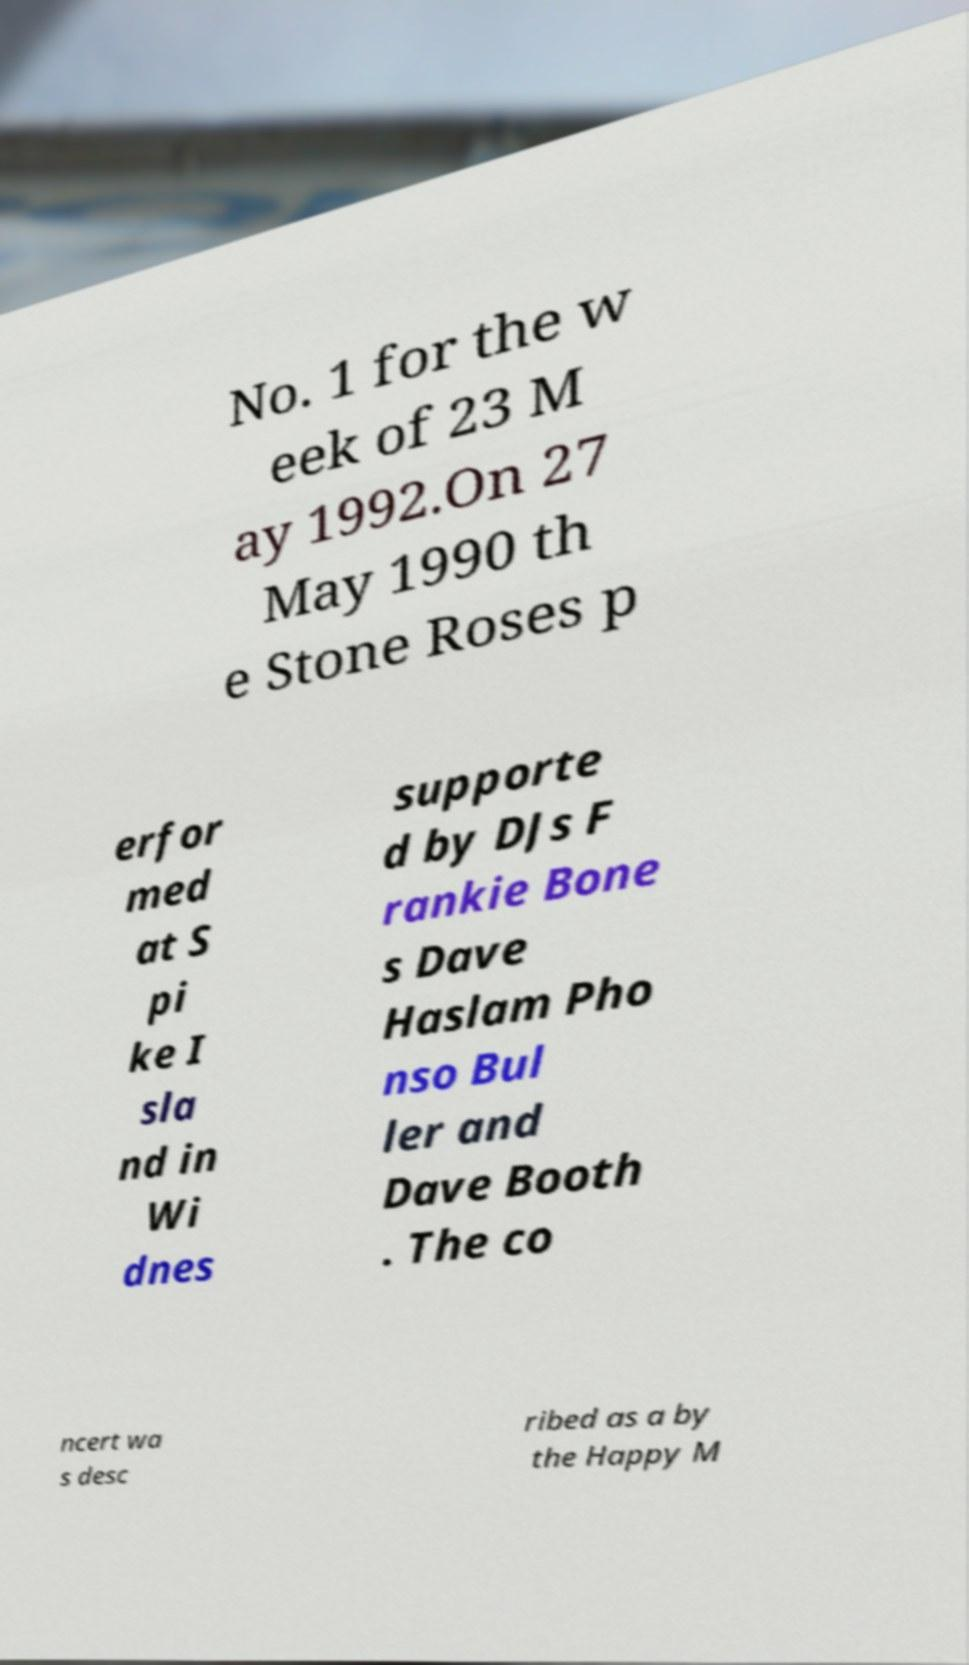Can you accurately transcribe the text from the provided image for me? No. 1 for the w eek of 23 M ay 1992.On 27 May 1990 th e Stone Roses p erfor med at S pi ke I sla nd in Wi dnes supporte d by DJs F rankie Bone s Dave Haslam Pho nso Bul ler and Dave Booth . The co ncert wa s desc ribed as a by the Happy M 